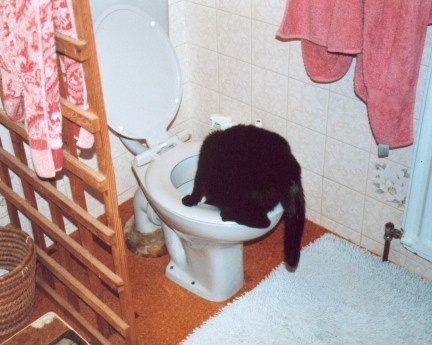Describe the objects in this image and their specific colors. I can see toilet in pink, lightgray, darkgray, and gray tones and cat in pink, black, gray, maroon, and darkgray tones in this image. 